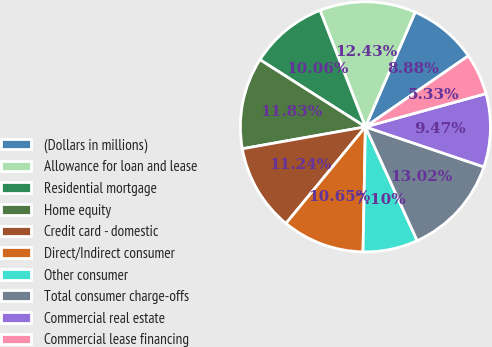Convert chart. <chart><loc_0><loc_0><loc_500><loc_500><pie_chart><fcel>(Dollars in millions)<fcel>Allowance for loan and lease<fcel>Residential mortgage<fcel>Home equity<fcel>Credit card - domestic<fcel>Direct/Indirect consumer<fcel>Other consumer<fcel>Total consumer charge-offs<fcel>Commercial real estate<fcel>Commercial lease financing<nl><fcel>8.88%<fcel>12.43%<fcel>10.06%<fcel>11.83%<fcel>11.24%<fcel>10.65%<fcel>7.1%<fcel>13.02%<fcel>9.47%<fcel>5.33%<nl></chart> 